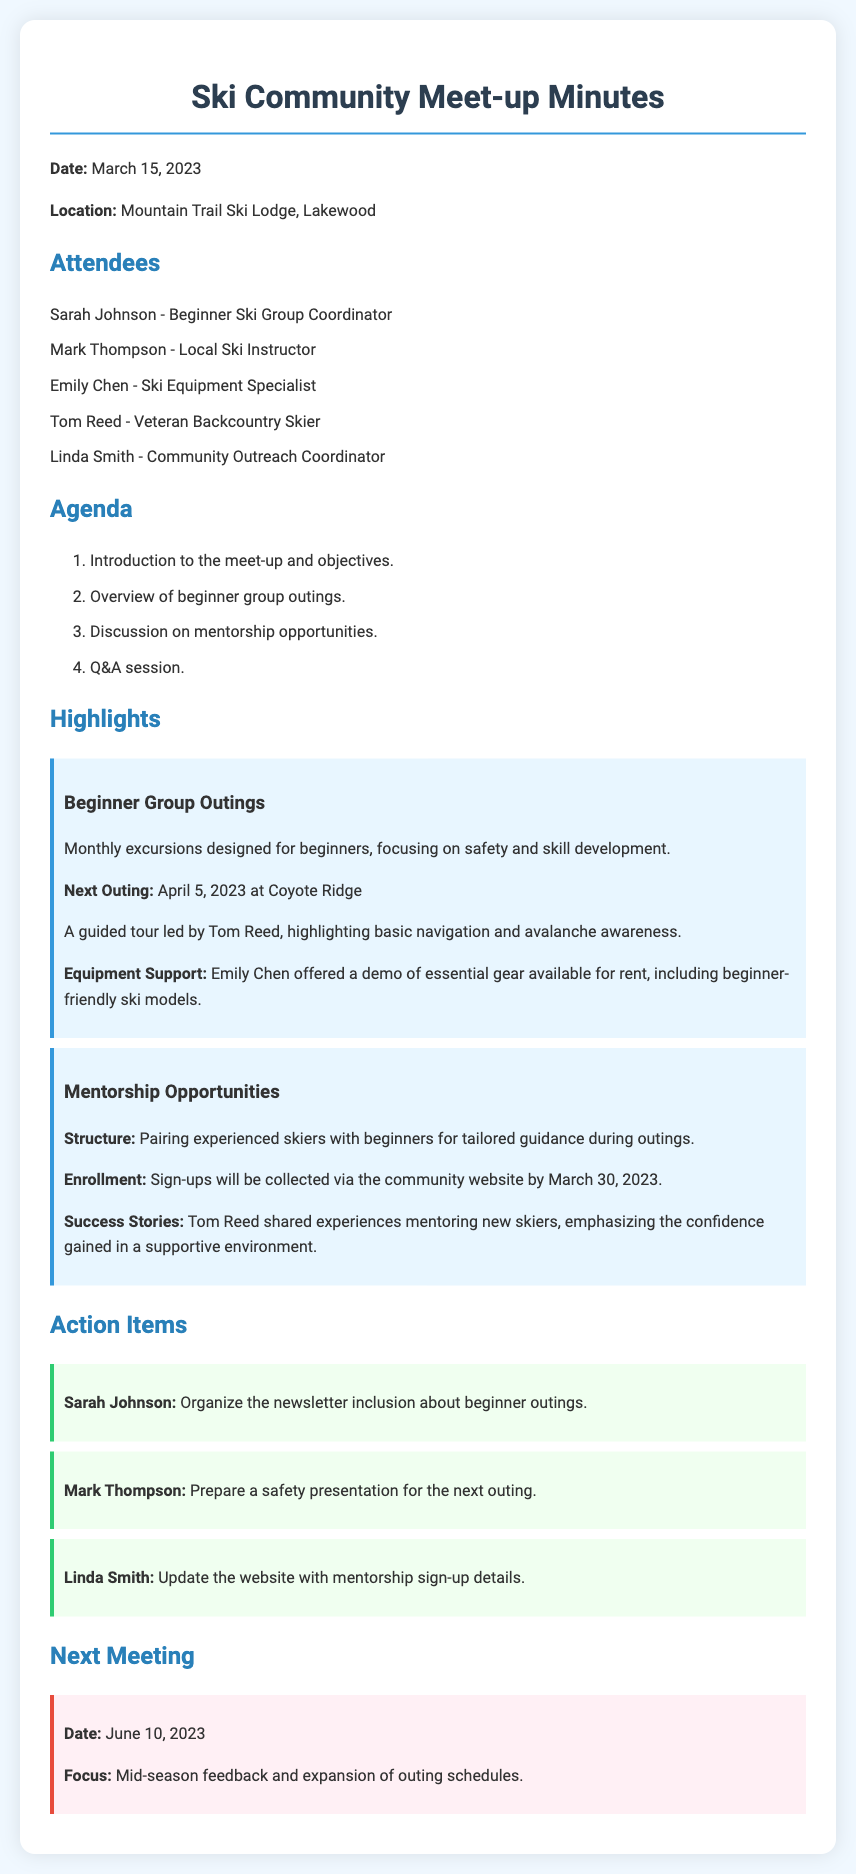what is the date of the meeting? The date of the meeting is mentioned at the beginning of the document.
Answer: March 15, 2023 who is the Beginner Ski Group Coordinator? The name of the Beginner Ski Group Coordinator is listed among the attendees.
Answer: Sarah Johnson what is the focus of the next meeting? The focus of the next meeting is outlined in the corresponding section.
Answer: Mid-season feedback and expansion of outing schedules when is the next beginner group outing scheduled? The date for the next beginner group outing is listed under the highlights section.
Answer: April 5, 2023 who led the guided tour for the next outing? The person leading the guided tour is mentioned in the highlights about beginner group outings.
Answer: Tom Reed what will be included in the newsletter? The action item indicates what Sarah Johnson will organize for the newsletter.
Answer: Beginner outings how will mentorship sign-ups be collected? The method for collecting mentorship sign-ups is stated in the highlights section.
Answer: Community website what type of presentation is Mark Thompson preparing? The action item specifies the type of presentation being prepared by Mark Thompson.
Answer: Safety presentation 